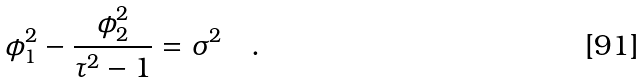Convert formula to latex. <formula><loc_0><loc_0><loc_500><loc_500>\phi _ { 1 } ^ { 2 } - \frac { \phi _ { 2 } ^ { 2 } } { \tau ^ { 2 } - 1 } = \sigma ^ { 2 } \quad .</formula> 